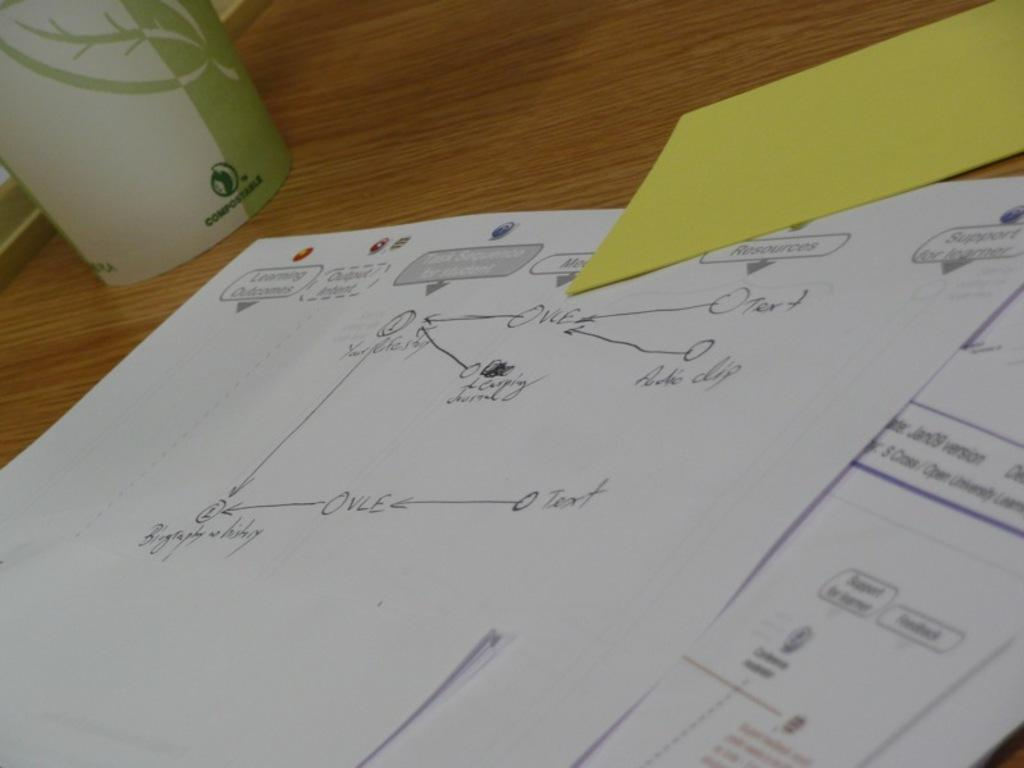Provide a one-sentence caption for the provided image. A piece of paper has a diagram with OVLE on it. 